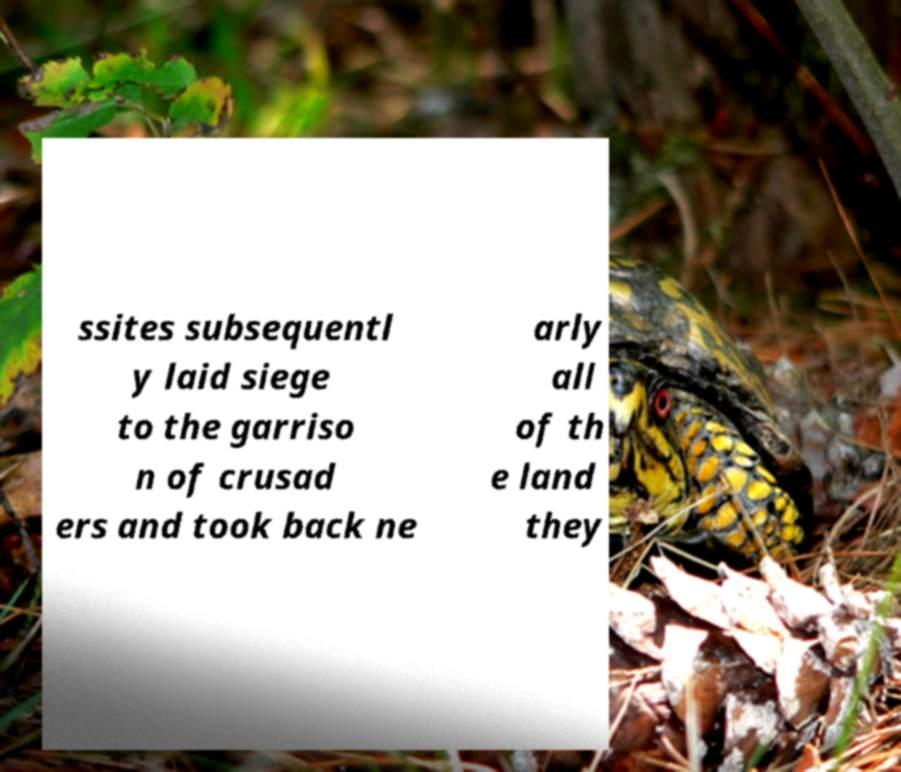Please read and relay the text visible in this image. What does it say? ssites subsequentl y laid siege to the garriso n of crusad ers and took back ne arly all of th e land they 